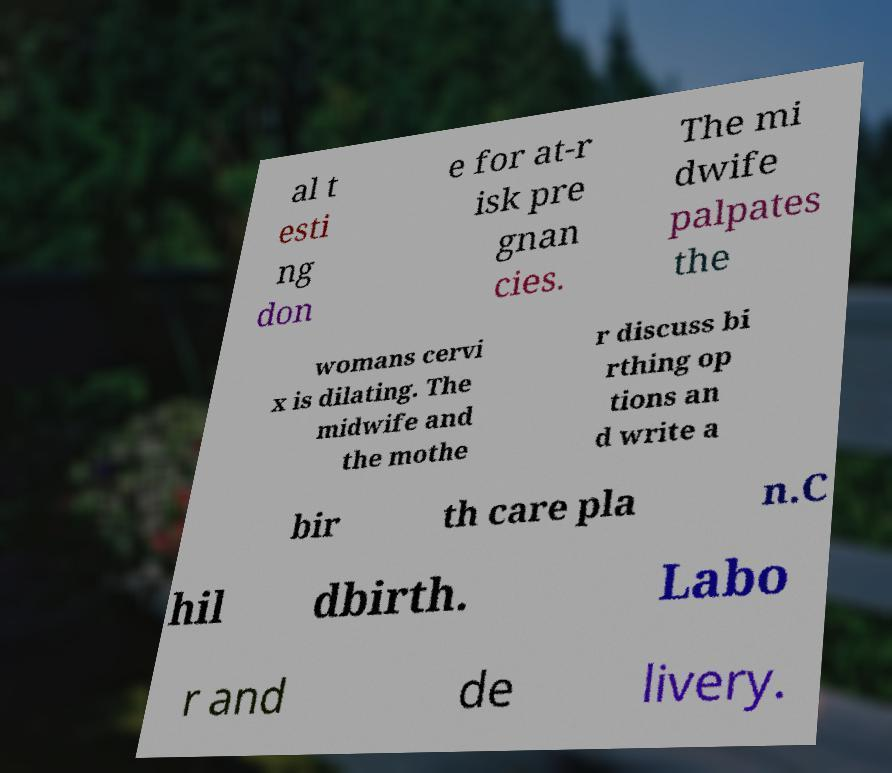What messages or text are displayed in this image? I need them in a readable, typed format. al t esti ng don e for at-r isk pre gnan cies. The mi dwife palpates the womans cervi x is dilating. The midwife and the mothe r discuss bi rthing op tions an d write a bir th care pla n.C hil dbirth. Labo r and de livery. 